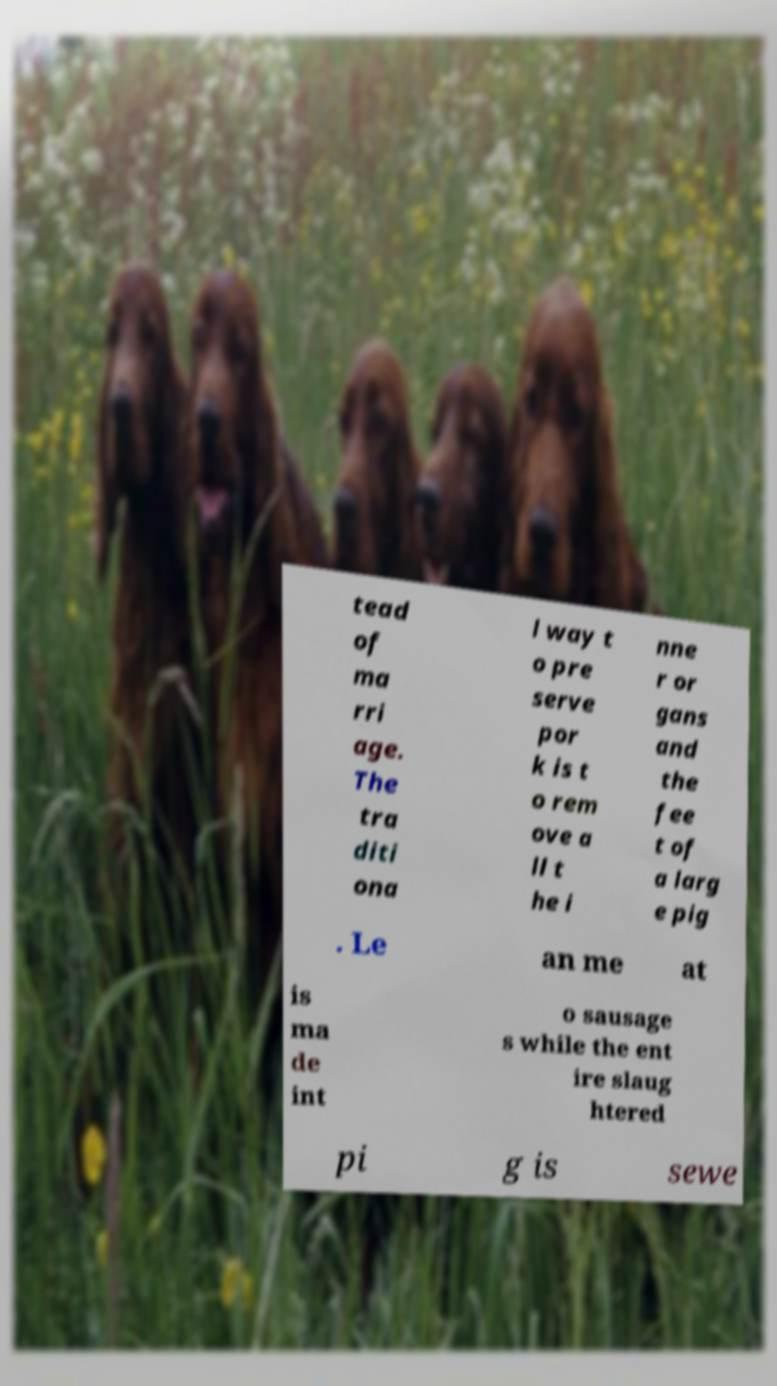Please identify and transcribe the text found in this image. tead of ma rri age. The tra diti ona l way t o pre serve por k is t o rem ove a ll t he i nne r or gans and the fee t of a larg e pig . Le an me at is ma de int o sausage s while the ent ire slaug htered pi g is sewe 